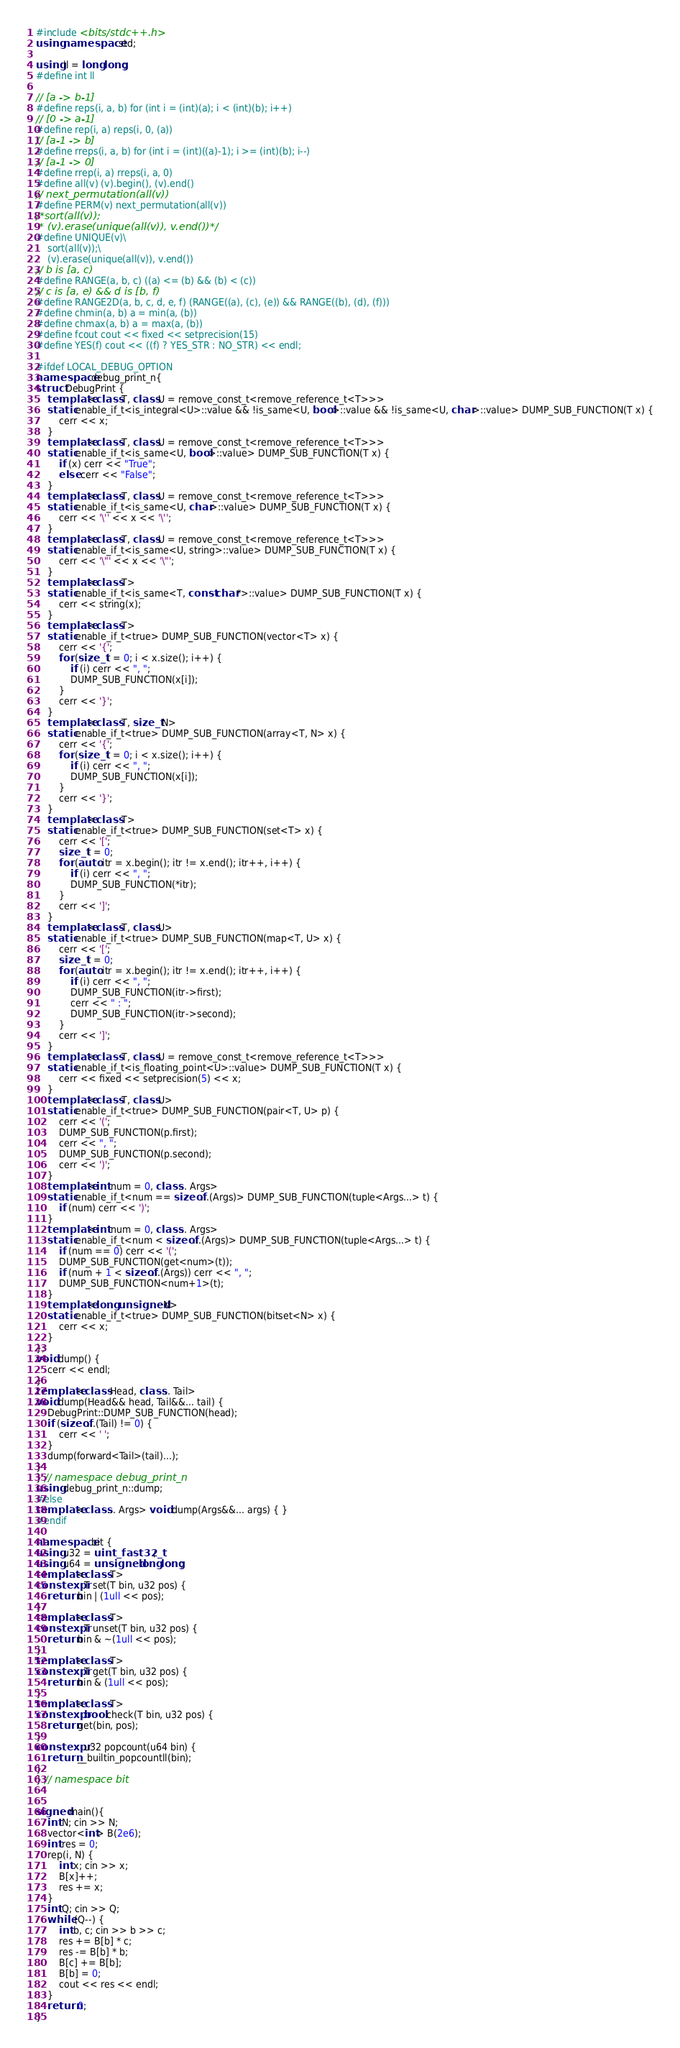<code> <loc_0><loc_0><loc_500><loc_500><_C++_>#include <bits/stdc++.h>
using namespace std;

using ll = long long;
#define int ll

// [a -> b-1]
#define reps(i, a, b) for (int i = (int)(a); i < (int)(b); i++)
// [0 -> a-1]
#define rep(i, a) reps(i, 0, (a))
// [a-1 -> b]
#define rreps(i, a, b) for (int i = (int)((a)-1); i >= (int)(b); i--)
// [a-1 -> 0]
#define rrep(i, a) rreps(i, a, 0)
#define all(v) (v).begin(), (v).end()
// next_permutation(all(v))
#define PERM(v) next_permutation(all(v))
/*sort(all(v));
 * (v).erase(unique(all(v)), v.end())*/
#define UNIQUE(v)\
	sort(all(v));\
	(v).erase(unique(all(v)), v.end())
// b is [a, c)
#define RANGE(a, b, c) ((a) <= (b) && (b) < (c))
// c is [a, e) && d is [b, f)
#define RANGE2D(a, b, c, d, e, f) (RANGE((a), (c), (e)) && RANGE((b), (d), (f)))
#define chmin(a, b) a = min(a, (b))
#define chmax(a, b) a = max(a, (b))
#define fcout cout << fixed << setprecision(15)
#define YES(f) cout << ((f) ? YES_STR : NO_STR) << endl;

#ifdef LOCAL_DEBUG_OPTION
namespace debug_print_n{
struct DebugPrint {
	template<class T, class U = remove_const_t<remove_reference_t<T>>>
	static enable_if_t<is_integral<U>::value && !is_same<U, bool>::value && !is_same<U, char>::value> DUMP_SUB_FUNCTION(T x) {
		cerr << x;
	}
	template<class T, class U = remove_const_t<remove_reference_t<T>>>
	static enable_if_t<is_same<U, bool>::value> DUMP_SUB_FUNCTION(T x) {
		if (x) cerr << "True";
		else cerr << "False";
	}
	template<class T, class U = remove_const_t<remove_reference_t<T>>>
	static enable_if_t<is_same<U, char>::value> DUMP_SUB_FUNCTION(T x) {
		cerr << '\'' << x << '\'';
	}
	template<class T, class U = remove_const_t<remove_reference_t<T>>>
	static enable_if_t<is_same<U, string>::value> DUMP_SUB_FUNCTION(T x) {
		cerr << '\"' << x << '\"';
	}
	template<class T>
	static enable_if_t<is_same<T, const char*>::value> DUMP_SUB_FUNCTION(T x) {
		cerr << string(x);
	}
	template<class T>
	static enable_if_t<true> DUMP_SUB_FUNCTION(vector<T> x) {
		cerr << '{';
		for (size_t i = 0; i < x.size(); i++) {
			if (i) cerr << ", ";
			DUMP_SUB_FUNCTION(x[i]);
		}
		cerr << '}';
	}
	template<class T, size_t N>
	static enable_if_t<true> DUMP_SUB_FUNCTION(array<T, N> x) {
		cerr << '{';
		for (size_t i = 0; i < x.size(); i++) {
			if (i) cerr << ", ";
			DUMP_SUB_FUNCTION(x[i]);
		}
		cerr << '}';
	}
	template<class T>
	static enable_if_t<true> DUMP_SUB_FUNCTION(set<T> x) {
		cerr << '[';
		size_t i = 0;
		for (auto itr = x.begin(); itr != x.end(); itr++, i++) {
			if (i) cerr << ", ";
			DUMP_SUB_FUNCTION(*itr);
		}
		cerr << ']';
	}
	template<class T, class U>
	static enable_if_t<true> DUMP_SUB_FUNCTION(map<T, U> x) {
		cerr << '[';
		size_t i = 0;
		for (auto itr = x.begin(); itr != x.end(); itr++, i++) {
			if (i) cerr << ", ";
			DUMP_SUB_FUNCTION(itr->first);
			cerr << " : ";
			DUMP_SUB_FUNCTION(itr->second);
		}
		cerr << ']';
	}
	template<class T, class U = remove_const_t<remove_reference_t<T>>>
	static enable_if_t<is_floating_point<U>::value> DUMP_SUB_FUNCTION(T x) {
		cerr << fixed << setprecision(5) << x;
	}
	template<class T, class U>
	static enable_if_t<true> DUMP_SUB_FUNCTION(pair<T, U> p) {
		cerr << '(';
		DUMP_SUB_FUNCTION(p.first);
		cerr << ", ";
		DUMP_SUB_FUNCTION(p.second);
		cerr << ')';
	}
	template<int num = 0, class... Args>
	static enable_if_t<num == sizeof...(Args)> DUMP_SUB_FUNCTION(tuple<Args...> t) {
		if (num) cerr << ')';
	}
	template<int num = 0, class... Args>
	static enable_if_t<num < sizeof...(Args)> DUMP_SUB_FUNCTION(tuple<Args...> t) {
		if (num == 0) cerr << '(';
		DUMP_SUB_FUNCTION(get<num>(t));
		if (num + 1 < sizeof...(Args)) cerr << ", ";
		DUMP_SUB_FUNCTION<num+1>(t);
	}
	template<long unsigned N>
	static enable_if_t<true> DUMP_SUB_FUNCTION(bitset<N> x) {
		cerr << x;
	}
};
void dump() {
	cerr << endl;
}
template<class Head, class... Tail>
void dump(Head&& head, Tail&&... tail) {
	DebugPrint::DUMP_SUB_FUNCTION(head);
	if (sizeof...(Tail) != 0) {
		cerr << ' ';
	}
	dump(forward<Tail>(tail)...);
}
} // namespace debug_print_n
using debug_print_n::dump;
#else
template<class... Args> void dump(Args&&... args) { }
#endif

namespace bit {
using u32 = uint_fast32_t;
using u64 = unsigned long long;
template<class T>
constexpr T set(T bin, u32 pos) {
	return bin | (1ull << pos);
}
template<class T>
constexpr T unset(T bin, u32 pos) {
	return bin & ~(1ull << pos);
}
template<class T>
constexpr T get(T bin, u32 pos) {
	return bin & (1ull << pos);
}
template<class T>
constexpr bool check(T bin, u32 pos) {
	return get(bin, pos);
}
constexpr u32 popcount(u64 bin) {
	return __builtin_popcountll(bin);
}
} // namespace bit


signed main(){
	int N; cin >> N;
	vector<int> B(2e6);
	int res = 0;
	rep(i, N) {
		int x; cin >> x;
		B[x]++;
		res += x;
	}
	int Q; cin >> Q;
	while (Q--) {
		int b, c; cin >> b >> c;
		res += B[b] * c;
		res -= B[b] * b;
		B[c] += B[b];
		B[b] = 0;
		cout << res << endl;
	}
	return 0;
}
</code> 